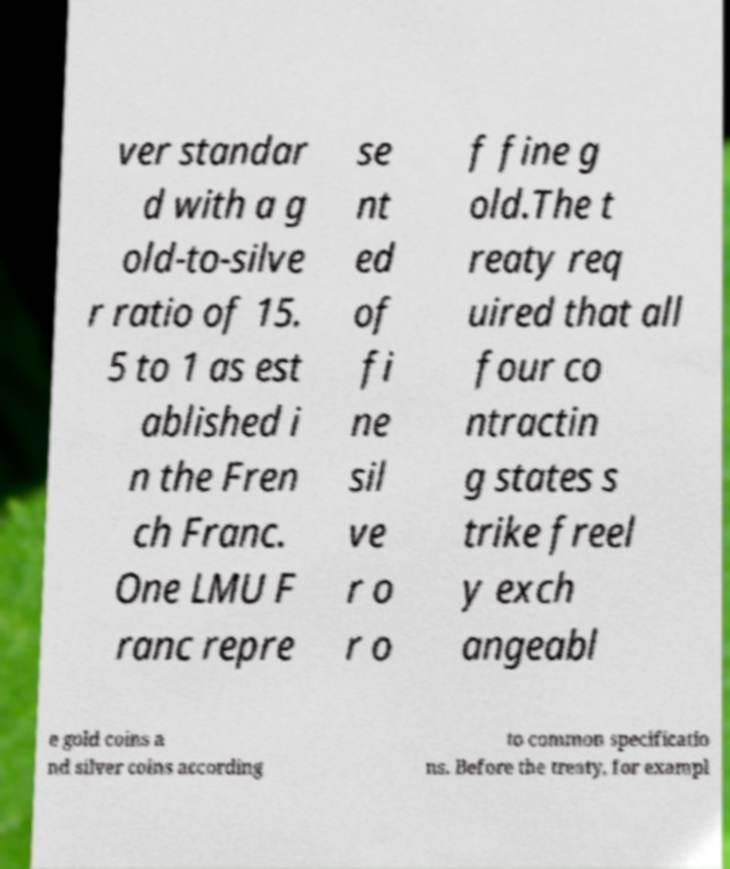Could you extract and type out the text from this image? ver standar d with a g old-to-silve r ratio of 15. 5 to 1 as est ablished i n the Fren ch Franc. One LMU F ranc repre se nt ed of fi ne sil ve r o r o f fine g old.The t reaty req uired that all four co ntractin g states s trike freel y exch angeabl e gold coins a nd silver coins according to common specificatio ns. Before the treaty, for exampl 